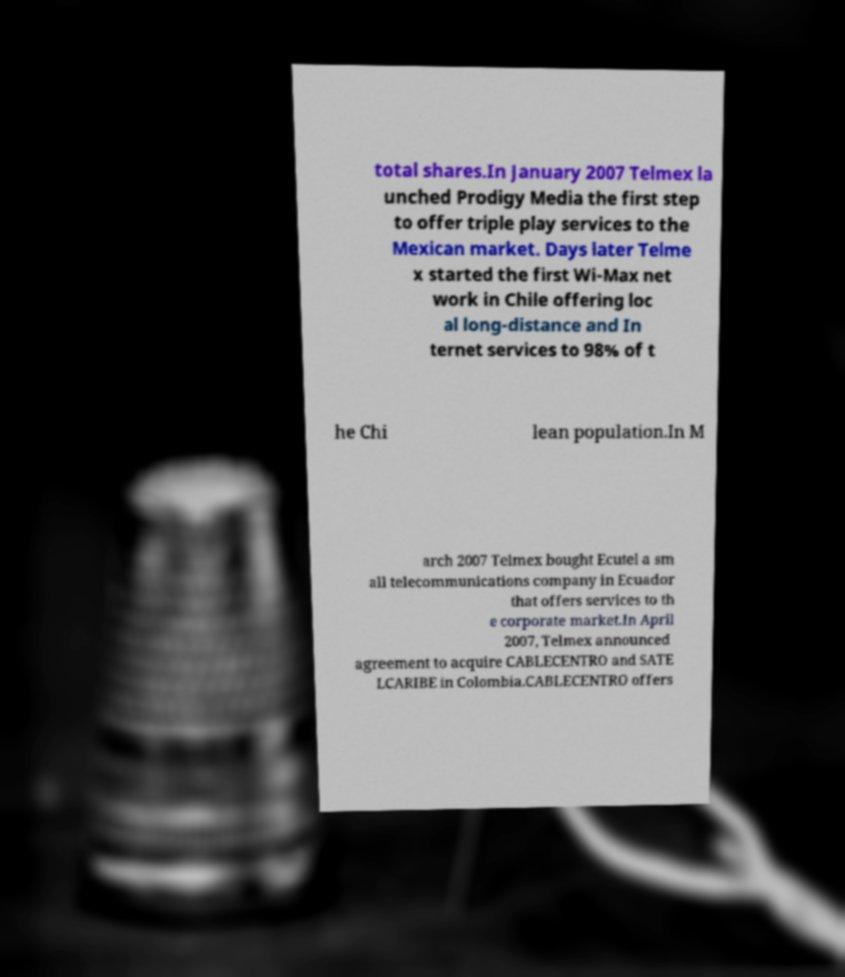Please read and relay the text visible in this image. What does it say? total shares.In January 2007 Telmex la unched Prodigy Media the first step to offer triple play services to the Mexican market. Days later Telme x started the first Wi-Max net work in Chile offering loc al long-distance and In ternet services to 98% of t he Chi lean population.In M arch 2007 Telmex bought Ecutel a sm all telecommunications company in Ecuador that offers services to th e corporate market.In April 2007, Telmex announced agreement to acquire CABLECENTRO and SATE LCARIBE in Colombia.CABLECENTRO offers 